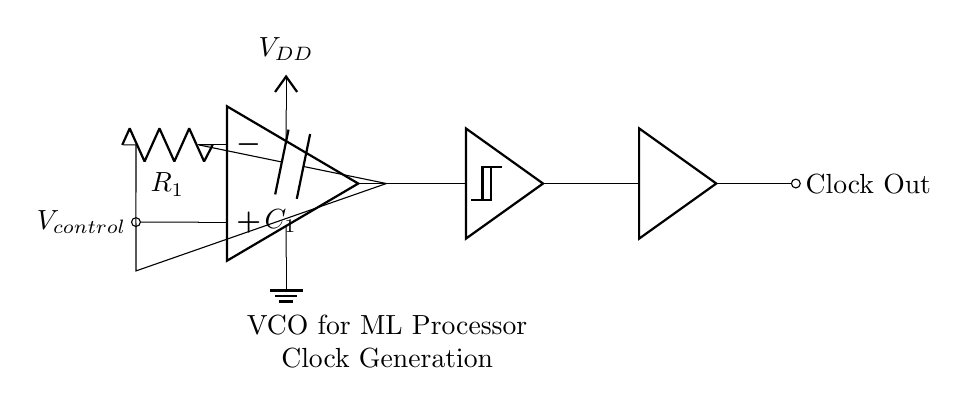What is the type of the main amplifying component in this circuit? The main amplifying component is an operational amplifier, as indicated by the symbol used in the circuit.
Answer: operational amplifier What does the control voltage affect in this circuit? The control voltage, denoted as V control, affects the frequency of oscillation generated by the VCO. This is common in voltage-controlled oscillators where the output frequency is modulated by the input control voltage.
Answer: frequency of oscillation What component is used for frequency stabilization in the VCO circuit? In this circuit, the capacitor, labeled as C1, works with the resistor R1 to determine the oscillation frequency by creating a feedback loop that stabilizes the oscillation.
Answer: capacitor Which component is responsible for shaping the clock signal output? The Schmitt trigger is responsible for shaping the clock signal output. It ensures a clean digital signal by providing hysteresis, making the transitions between high and low states more defined.
Answer: Schmitt trigger What is the purpose of the buffer in this circuit? The buffer is used to isolate the output of the Schmitt trigger from the load connected to the clock output, providing a high current output without affecting the oscillation characteristics of the circuit.
Answer: isolation 